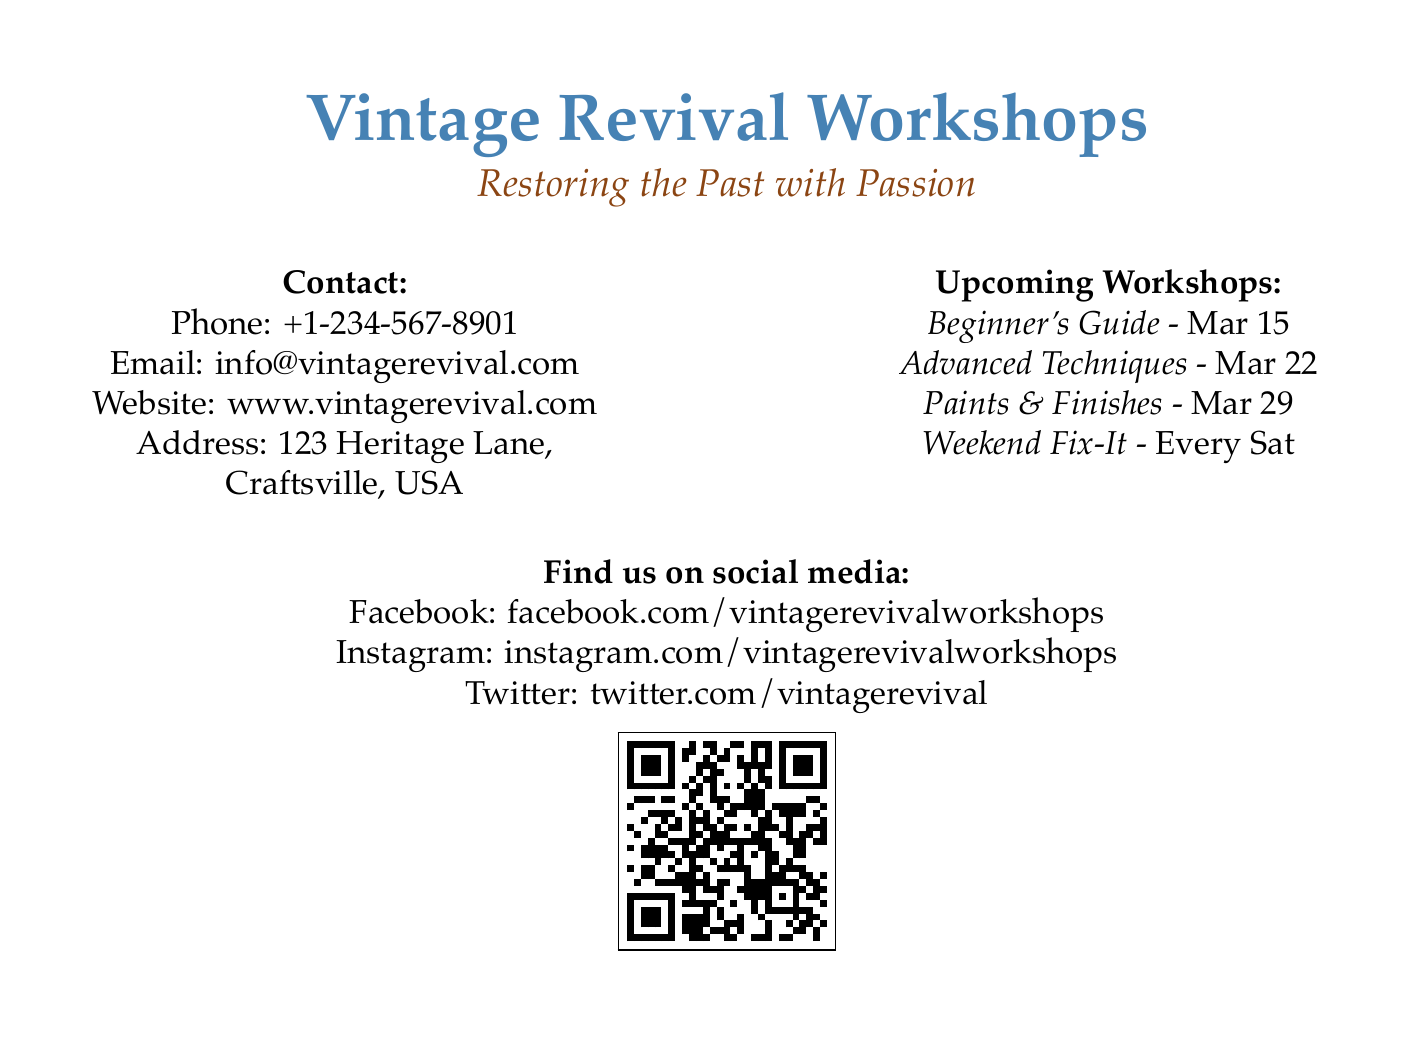What is the phone number for Vintage Revival Workshops? The phone number is listed under the contact section of the document.
Answer: +1-234-567-8901 When is the Beginner's Guide workshop scheduled? The date for the Beginner's Guide workshop is mentioned in the upcoming workshops section.
Answer: Mar 15 How many workshops are listed in total? The total number of workshops can be counted from the upcoming workshops section.
Answer: 4 What color is used for the workshop’s title? The title "Vintage Revival Workshops" is colored vintage blue as specified in the document.
Answer: vintage blue Which social media platform is mentioned last? The last social media platform listed in the document is mentioned after the contact details.
Answer: Twitter 